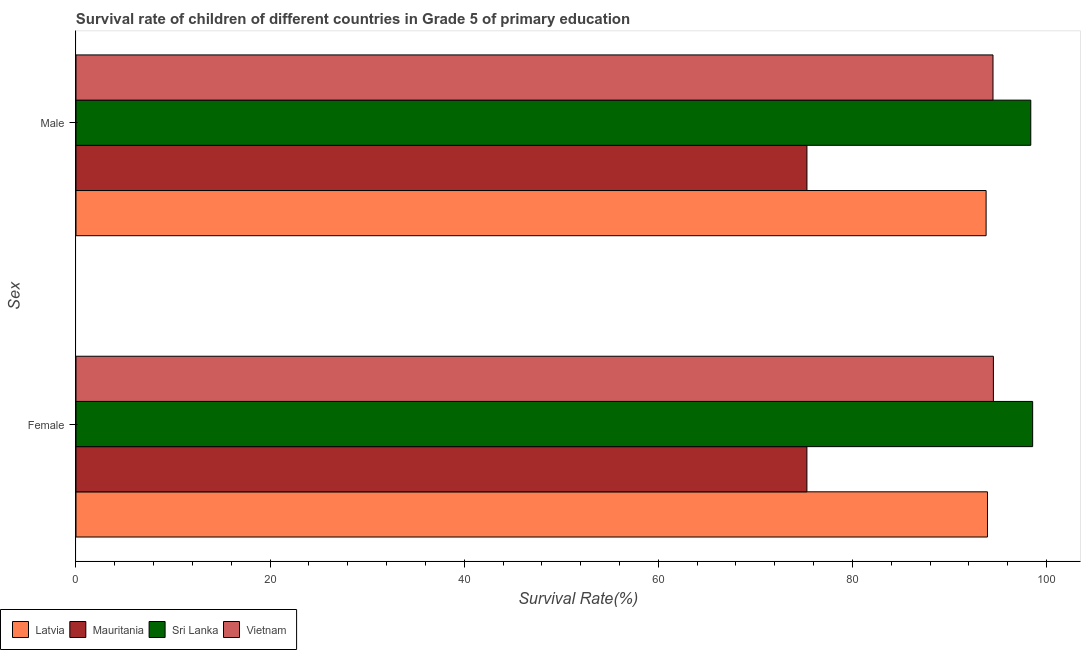How many different coloured bars are there?
Keep it short and to the point. 4. What is the survival rate of female students in primary education in Mauritania?
Offer a very short reply. 75.31. Across all countries, what is the maximum survival rate of female students in primary education?
Ensure brevity in your answer.  98.57. Across all countries, what is the minimum survival rate of male students in primary education?
Your response must be concise. 75.31. In which country was the survival rate of female students in primary education maximum?
Offer a very short reply. Sri Lanka. In which country was the survival rate of male students in primary education minimum?
Keep it short and to the point. Mauritania. What is the total survival rate of male students in primary education in the graph?
Provide a succinct answer. 361.95. What is the difference between the survival rate of female students in primary education in Sri Lanka and that in Vietnam?
Your response must be concise. 4.05. What is the difference between the survival rate of male students in primary education in Mauritania and the survival rate of female students in primary education in Latvia?
Make the answer very short. -18.6. What is the average survival rate of male students in primary education per country?
Give a very brief answer. 90.49. What is the difference between the survival rate of female students in primary education and survival rate of male students in primary education in Vietnam?
Provide a short and direct response. 0.04. What is the ratio of the survival rate of female students in primary education in Mauritania to that in Sri Lanka?
Your answer should be compact. 0.76. Is the survival rate of male students in primary education in Latvia less than that in Vietnam?
Provide a succinct answer. Yes. In how many countries, is the survival rate of male students in primary education greater than the average survival rate of male students in primary education taken over all countries?
Give a very brief answer. 3. What does the 1st bar from the top in Male represents?
Make the answer very short. Vietnam. What does the 1st bar from the bottom in Male represents?
Your response must be concise. Latvia. How many countries are there in the graph?
Give a very brief answer. 4. Are the values on the major ticks of X-axis written in scientific E-notation?
Keep it short and to the point. No. Does the graph contain any zero values?
Your answer should be compact. No. Does the graph contain grids?
Keep it short and to the point. No. How many legend labels are there?
Provide a short and direct response. 4. What is the title of the graph?
Your response must be concise. Survival rate of children of different countries in Grade 5 of primary education. Does "South Sudan" appear as one of the legend labels in the graph?
Keep it short and to the point. No. What is the label or title of the X-axis?
Make the answer very short. Survival Rate(%). What is the label or title of the Y-axis?
Your answer should be compact. Sex. What is the Survival Rate(%) of Latvia in Female?
Provide a succinct answer. 93.92. What is the Survival Rate(%) of Mauritania in Female?
Provide a succinct answer. 75.31. What is the Survival Rate(%) of Sri Lanka in Female?
Offer a very short reply. 98.57. What is the Survival Rate(%) of Vietnam in Female?
Offer a terse response. 94.52. What is the Survival Rate(%) of Latvia in Male?
Your response must be concise. 93.77. What is the Survival Rate(%) of Mauritania in Male?
Give a very brief answer. 75.31. What is the Survival Rate(%) in Sri Lanka in Male?
Keep it short and to the point. 98.38. What is the Survival Rate(%) of Vietnam in Male?
Ensure brevity in your answer.  94.48. Across all Sex, what is the maximum Survival Rate(%) of Latvia?
Offer a terse response. 93.92. Across all Sex, what is the maximum Survival Rate(%) in Mauritania?
Provide a succinct answer. 75.31. Across all Sex, what is the maximum Survival Rate(%) of Sri Lanka?
Provide a succinct answer. 98.57. Across all Sex, what is the maximum Survival Rate(%) in Vietnam?
Provide a succinct answer. 94.52. Across all Sex, what is the minimum Survival Rate(%) of Latvia?
Give a very brief answer. 93.77. Across all Sex, what is the minimum Survival Rate(%) of Mauritania?
Ensure brevity in your answer.  75.31. Across all Sex, what is the minimum Survival Rate(%) in Sri Lanka?
Offer a terse response. 98.38. Across all Sex, what is the minimum Survival Rate(%) of Vietnam?
Your answer should be compact. 94.48. What is the total Survival Rate(%) in Latvia in the graph?
Offer a terse response. 187.69. What is the total Survival Rate(%) in Mauritania in the graph?
Keep it short and to the point. 150.62. What is the total Survival Rate(%) in Sri Lanka in the graph?
Ensure brevity in your answer.  196.95. What is the total Survival Rate(%) in Vietnam in the graph?
Ensure brevity in your answer.  189.01. What is the difference between the Survival Rate(%) in Latvia in Female and that in Male?
Provide a succinct answer. 0.14. What is the difference between the Survival Rate(%) of Mauritania in Female and that in Male?
Offer a terse response. -0. What is the difference between the Survival Rate(%) of Sri Lanka in Female and that in Male?
Your answer should be compact. 0.19. What is the difference between the Survival Rate(%) in Vietnam in Female and that in Male?
Offer a terse response. 0.04. What is the difference between the Survival Rate(%) in Latvia in Female and the Survival Rate(%) in Mauritania in Male?
Your answer should be very brief. 18.6. What is the difference between the Survival Rate(%) of Latvia in Female and the Survival Rate(%) of Sri Lanka in Male?
Provide a succinct answer. -4.46. What is the difference between the Survival Rate(%) of Latvia in Female and the Survival Rate(%) of Vietnam in Male?
Offer a terse response. -0.57. What is the difference between the Survival Rate(%) in Mauritania in Female and the Survival Rate(%) in Sri Lanka in Male?
Provide a short and direct response. -23.07. What is the difference between the Survival Rate(%) in Mauritania in Female and the Survival Rate(%) in Vietnam in Male?
Offer a terse response. -19.17. What is the difference between the Survival Rate(%) of Sri Lanka in Female and the Survival Rate(%) of Vietnam in Male?
Make the answer very short. 4.09. What is the average Survival Rate(%) of Latvia per Sex?
Your answer should be compact. 93.84. What is the average Survival Rate(%) of Mauritania per Sex?
Provide a succinct answer. 75.31. What is the average Survival Rate(%) in Sri Lanka per Sex?
Your answer should be very brief. 98.47. What is the average Survival Rate(%) of Vietnam per Sex?
Offer a very short reply. 94.5. What is the difference between the Survival Rate(%) of Latvia and Survival Rate(%) of Mauritania in Female?
Provide a short and direct response. 18.61. What is the difference between the Survival Rate(%) in Latvia and Survival Rate(%) in Sri Lanka in Female?
Provide a succinct answer. -4.66. What is the difference between the Survival Rate(%) in Latvia and Survival Rate(%) in Vietnam in Female?
Ensure brevity in your answer.  -0.61. What is the difference between the Survival Rate(%) in Mauritania and Survival Rate(%) in Sri Lanka in Female?
Give a very brief answer. -23.26. What is the difference between the Survival Rate(%) in Mauritania and Survival Rate(%) in Vietnam in Female?
Provide a succinct answer. -19.21. What is the difference between the Survival Rate(%) in Sri Lanka and Survival Rate(%) in Vietnam in Female?
Ensure brevity in your answer.  4.05. What is the difference between the Survival Rate(%) of Latvia and Survival Rate(%) of Mauritania in Male?
Your answer should be compact. 18.46. What is the difference between the Survival Rate(%) in Latvia and Survival Rate(%) in Sri Lanka in Male?
Provide a succinct answer. -4.6. What is the difference between the Survival Rate(%) of Latvia and Survival Rate(%) of Vietnam in Male?
Ensure brevity in your answer.  -0.71. What is the difference between the Survival Rate(%) of Mauritania and Survival Rate(%) of Sri Lanka in Male?
Keep it short and to the point. -23.06. What is the difference between the Survival Rate(%) in Mauritania and Survival Rate(%) in Vietnam in Male?
Offer a terse response. -19.17. What is the difference between the Survival Rate(%) in Sri Lanka and Survival Rate(%) in Vietnam in Male?
Make the answer very short. 3.89. What is the ratio of the Survival Rate(%) in Vietnam in Female to that in Male?
Provide a short and direct response. 1. What is the difference between the highest and the second highest Survival Rate(%) of Latvia?
Keep it short and to the point. 0.14. What is the difference between the highest and the second highest Survival Rate(%) in Mauritania?
Keep it short and to the point. 0. What is the difference between the highest and the second highest Survival Rate(%) of Sri Lanka?
Your response must be concise. 0.19. What is the difference between the highest and the second highest Survival Rate(%) in Vietnam?
Provide a short and direct response. 0.04. What is the difference between the highest and the lowest Survival Rate(%) of Latvia?
Give a very brief answer. 0.14. What is the difference between the highest and the lowest Survival Rate(%) of Mauritania?
Keep it short and to the point. 0. What is the difference between the highest and the lowest Survival Rate(%) of Sri Lanka?
Your answer should be very brief. 0.19. What is the difference between the highest and the lowest Survival Rate(%) in Vietnam?
Your response must be concise. 0.04. 